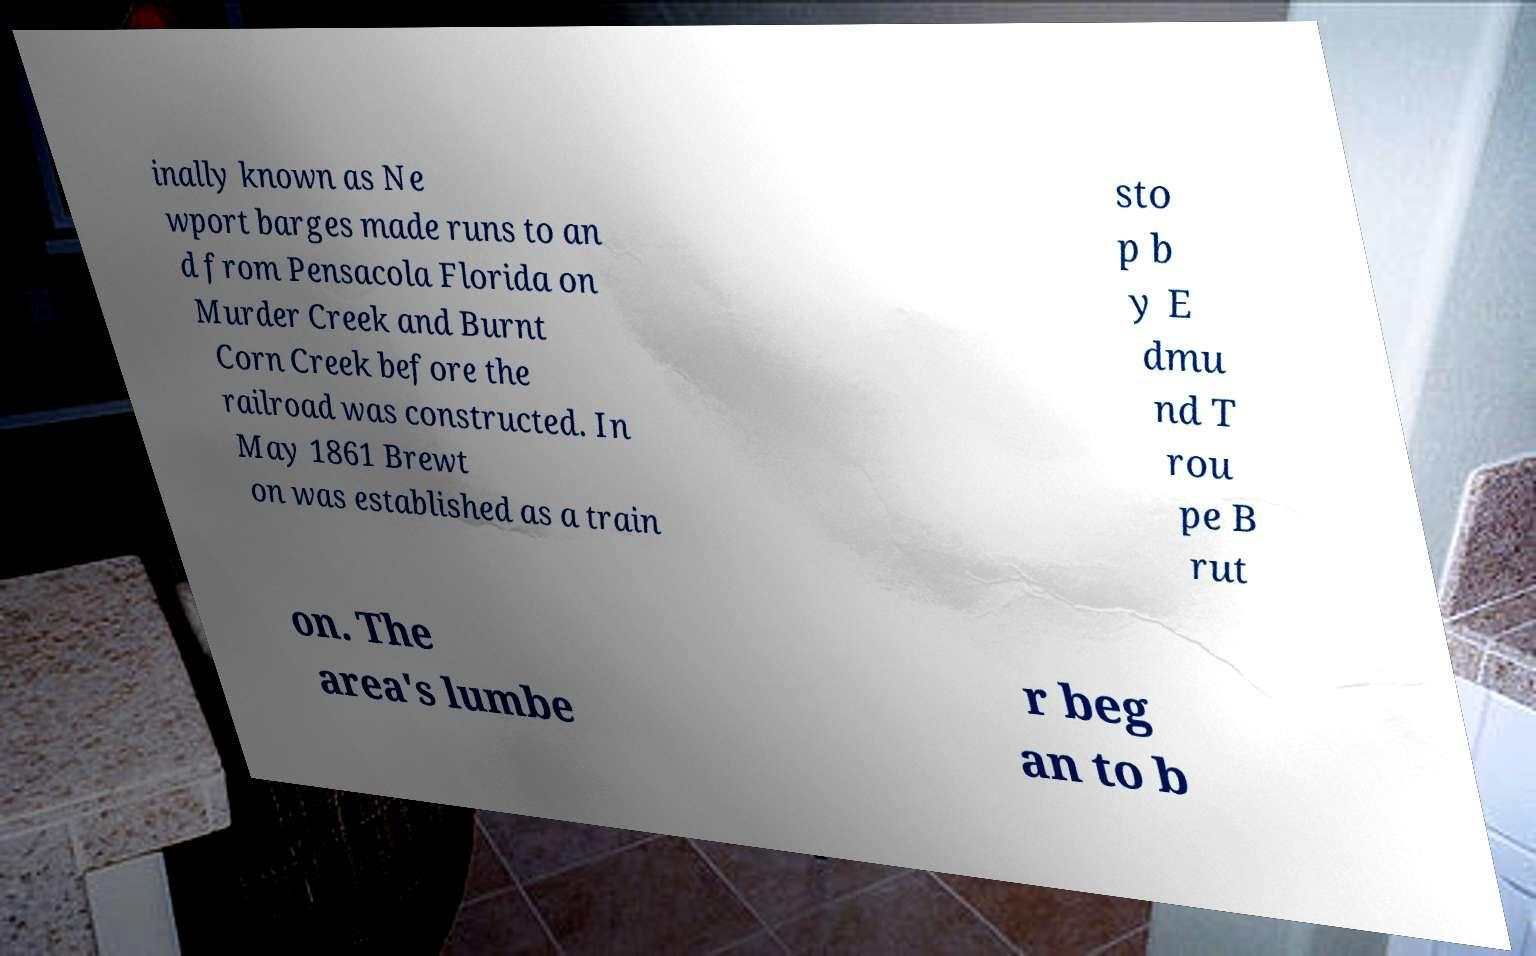There's text embedded in this image that I need extracted. Can you transcribe it verbatim? inally known as Ne wport barges made runs to an d from Pensacola Florida on Murder Creek and Burnt Corn Creek before the railroad was constructed. In May 1861 Brewt on was established as a train sto p b y E dmu nd T rou pe B rut on. The area's lumbe r beg an to b 